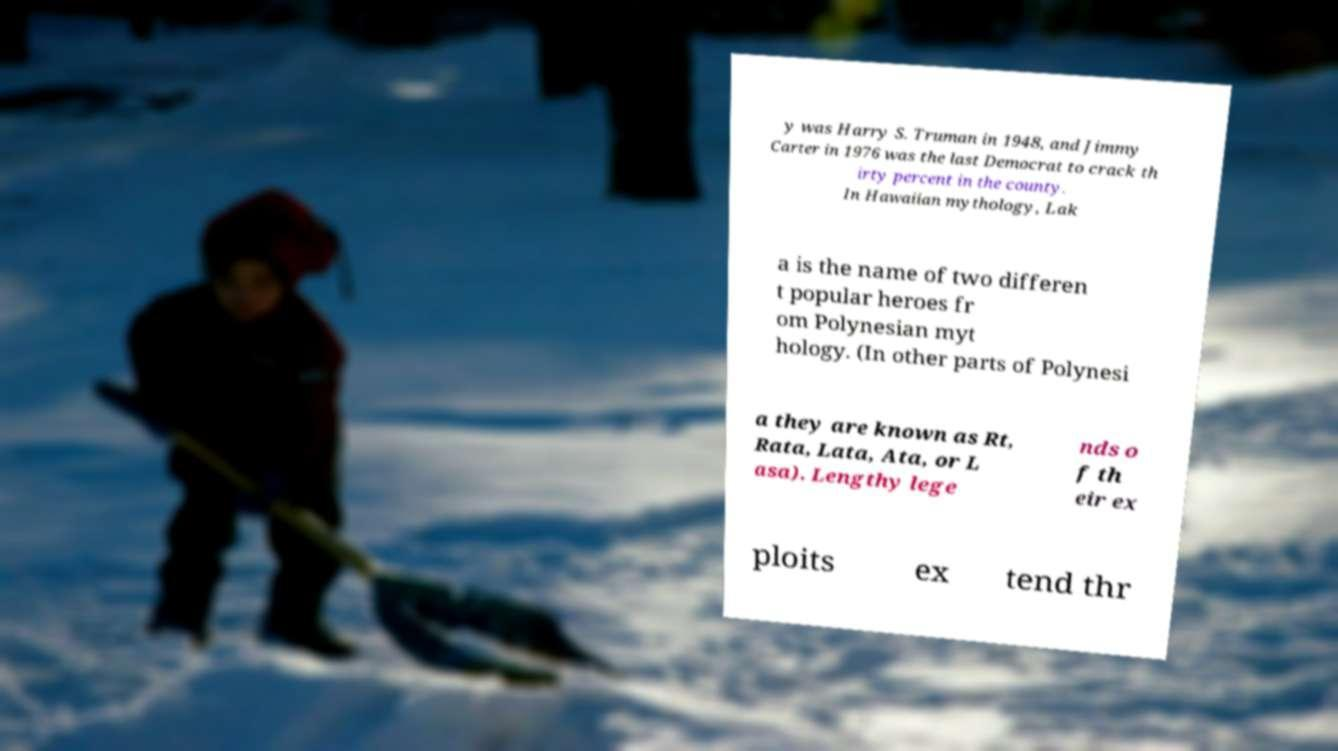Please identify and transcribe the text found in this image. y was Harry S. Truman in 1948, and Jimmy Carter in 1976 was the last Democrat to crack th irty percent in the county. In Hawaiian mythology, Lak a is the name of two differen t popular heroes fr om Polynesian myt hology. (In other parts of Polynesi a they are known as Rt, Rata, Lata, Ata, or L asa). Lengthy lege nds o f th eir ex ploits ex tend thr 